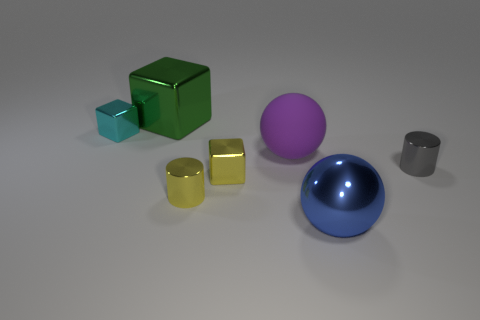Is the number of small things in front of the large blue shiny sphere the same as the number of large metal cubes?
Your response must be concise. No. What number of other things are made of the same material as the tiny cyan object?
Give a very brief answer. 5. Does the blue metal ball that is to the right of the matte sphere have the same size as the shiny thing on the right side of the blue metallic object?
Your answer should be compact. No. How many objects are either blocks behind the small gray shiny cylinder or shiny cylinders to the left of the small gray cylinder?
Offer a very short reply. 3. Is there any other thing that has the same shape as the small gray metal thing?
Make the answer very short. Yes. Is the color of the block in front of the large purple matte ball the same as the tiny metal block that is behind the gray cylinder?
Ensure brevity in your answer.  No. How many rubber objects are either small gray cylinders or blocks?
Ensure brevity in your answer.  0. Is there anything else that is the same size as the blue shiny sphere?
Make the answer very short. Yes. The yellow object behind the metal cylinder that is left of the blue metallic sphere is what shape?
Give a very brief answer. Cube. Do the large green thing behind the large purple ball and the tiny cube that is in front of the small cyan cube have the same material?
Give a very brief answer. Yes. 